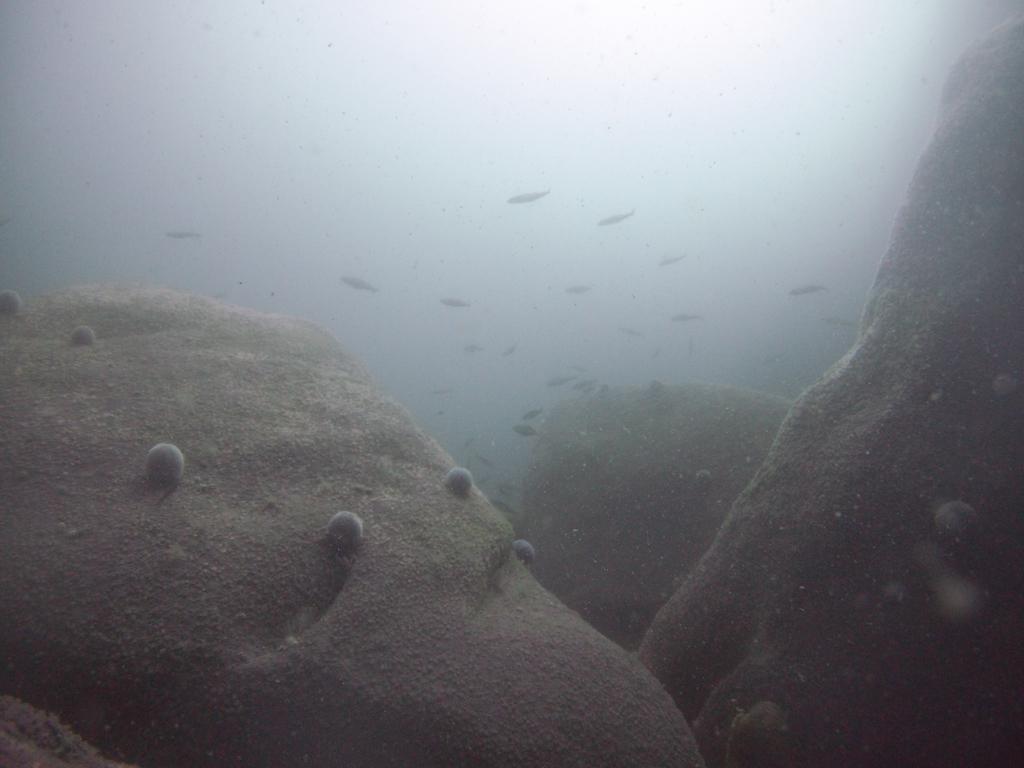Can you describe this image briefly? In this picture I can see the water. I can see the fishes. 